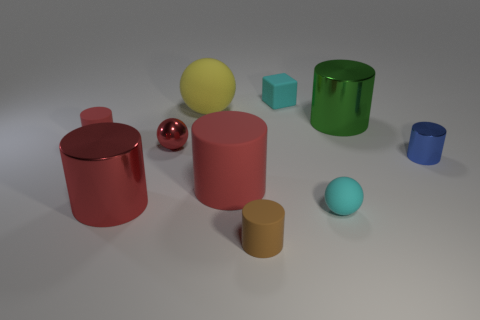Can you describe the lighting environment where these objects are placed? The lighting in the image is diffuse and seems to be cast from above, creating gentle shadows beneath the objects. This suggests an evenly lit indoor setting, such as a photo studio with a softbox or ambient light to minimize harsh shadows. The reflections on the glossy objects indicate a bright and broad light source. 